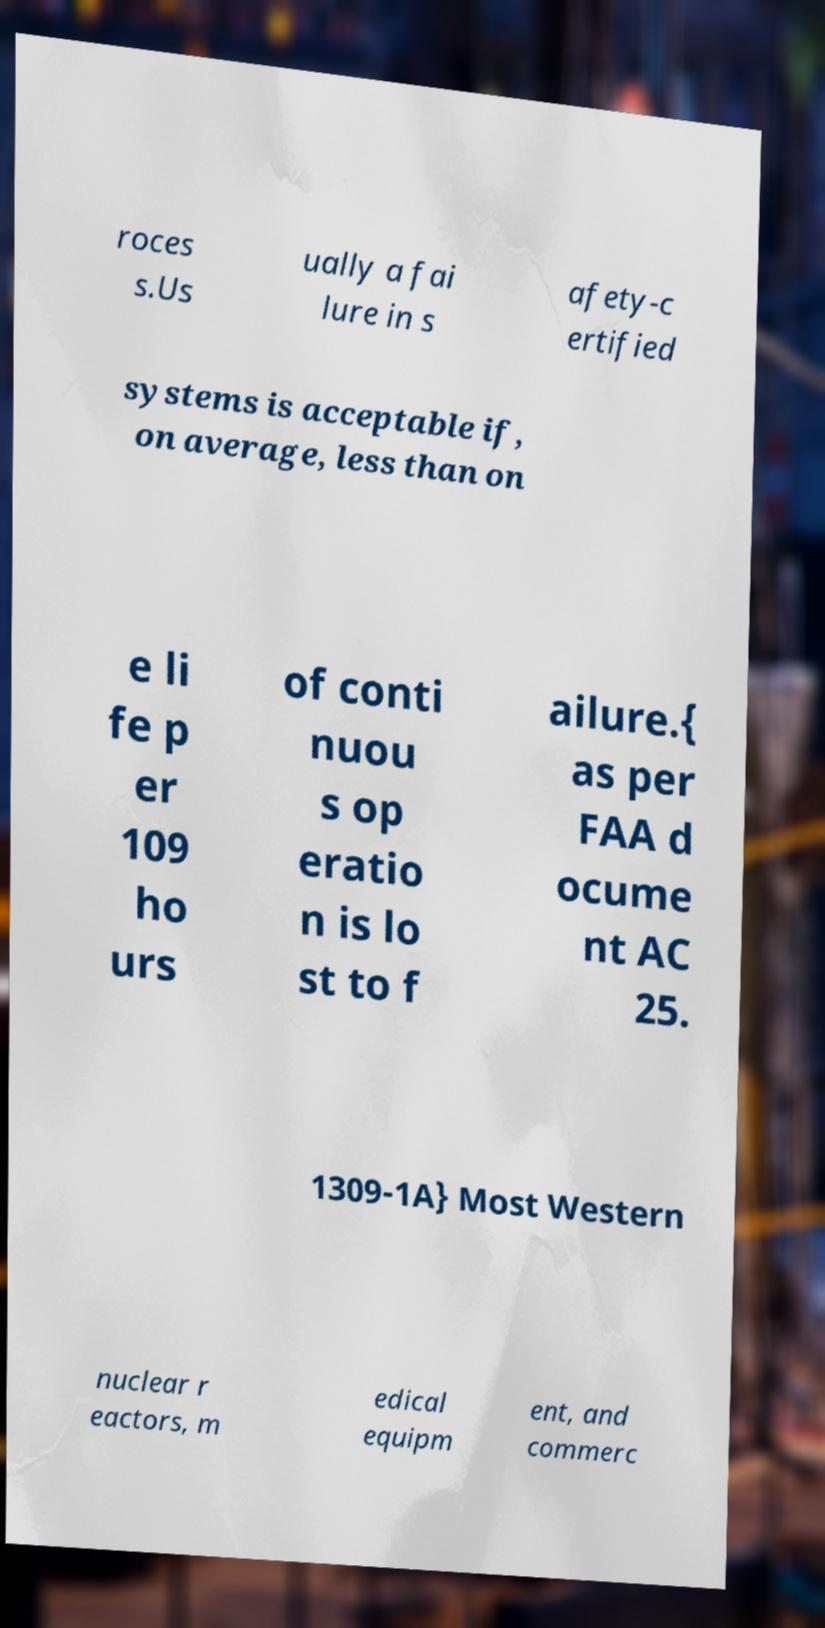Could you assist in decoding the text presented in this image and type it out clearly? roces s.Us ually a fai lure in s afety-c ertified systems is acceptable if, on average, less than on e li fe p er 109 ho urs of conti nuou s op eratio n is lo st to f ailure.{ as per FAA d ocume nt AC 25. 1309-1A} Most Western nuclear r eactors, m edical equipm ent, and commerc 